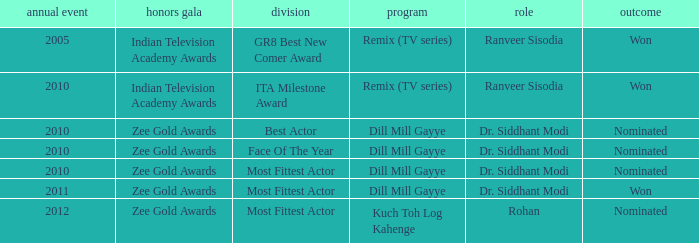Which show was nominated for the ITA Milestone Award at the Indian Television Academy Awards? Remix (TV series). 